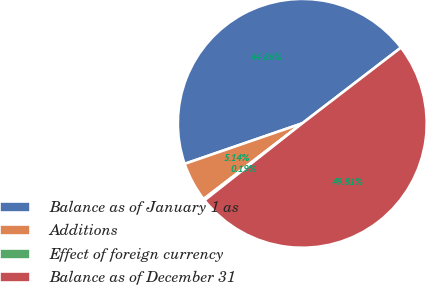Convert chart. <chart><loc_0><loc_0><loc_500><loc_500><pie_chart><fcel>Balance as of January 1 as<fcel>Additions<fcel>Effect of foreign currency<fcel>Balance as of December 31<nl><fcel>44.86%<fcel>5.14%<fcel>0.19%<fcel>49.81%<nl></chart> 